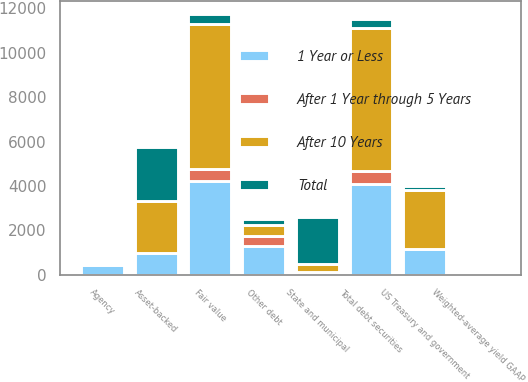Convert chart. <chart><loc_0><loc_0><loc_500><loc_500><stacked_bar_chart><ecel><fcel>US Treasury and government<fcel>Agency<fcel>Asset-backed<fcel>State and municipal<fcel>Other debt<fcel>Total debt securities<fcel>Fair value<fcel>Weighted-average yield GAAP<nl><fcel>After 1 Year through 5 Years<fcel>1<fcel>66<fcel>32<fcel>7<fcel>459<fcel>565<fcel>570<fcel>3.01<nl><fcel>1 Year or Less<fcel>1152<fcel>430<fcel>973<fcel>117<fcel>1301<fcel>4113<fcel>4209<fcel>2.49<nl><fcel>After 10 Years<fcel>2674<fcel>36<fcel>2335<fcel>349<fcel>475<fcel>6413<fcel>6524<fcel>2.36<nl><fcel>Total<fcel>163<fcel>100<fcel>2414<fcel>2136<fcel>271<fcel>444.5<fcel>444.5<fcel>3.16<nl></chart> 